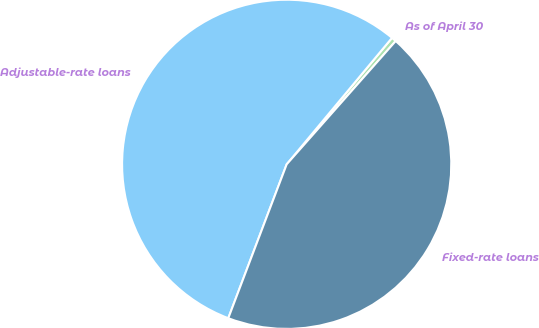Convert chart to OTSL. <chart><loc_0><loc_0><loc_500><loc_500><pie_chart><fcel>As of April 30<fcel>Adjustable-rate loans<fcel>Fixed-rate loans<nl><fcel>0.47%<fcel>55.28%<fcel>44.25%<nl></chart> 